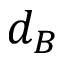<formula> <loc_0><loc_0><loc_500><loc_500>d _ { B }</formula> 